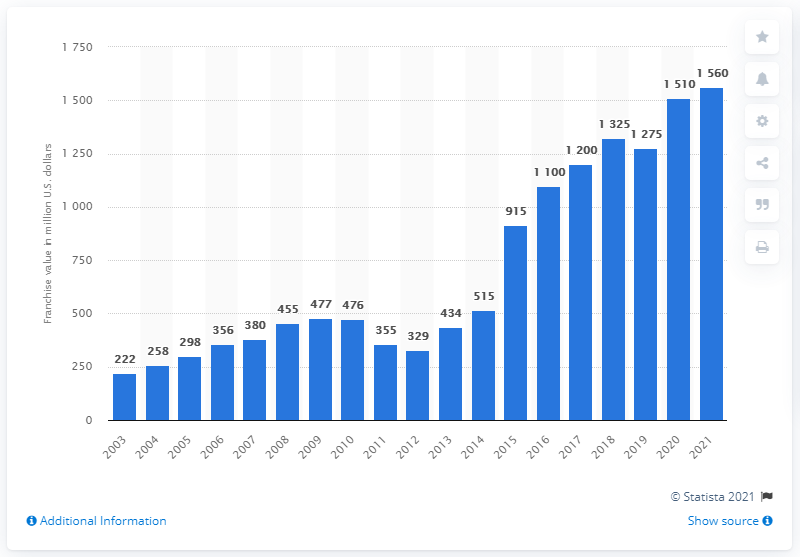Identify some key points in this picture. The estimated value of the Cleveland Cavaliers in 2021 was 1560. 